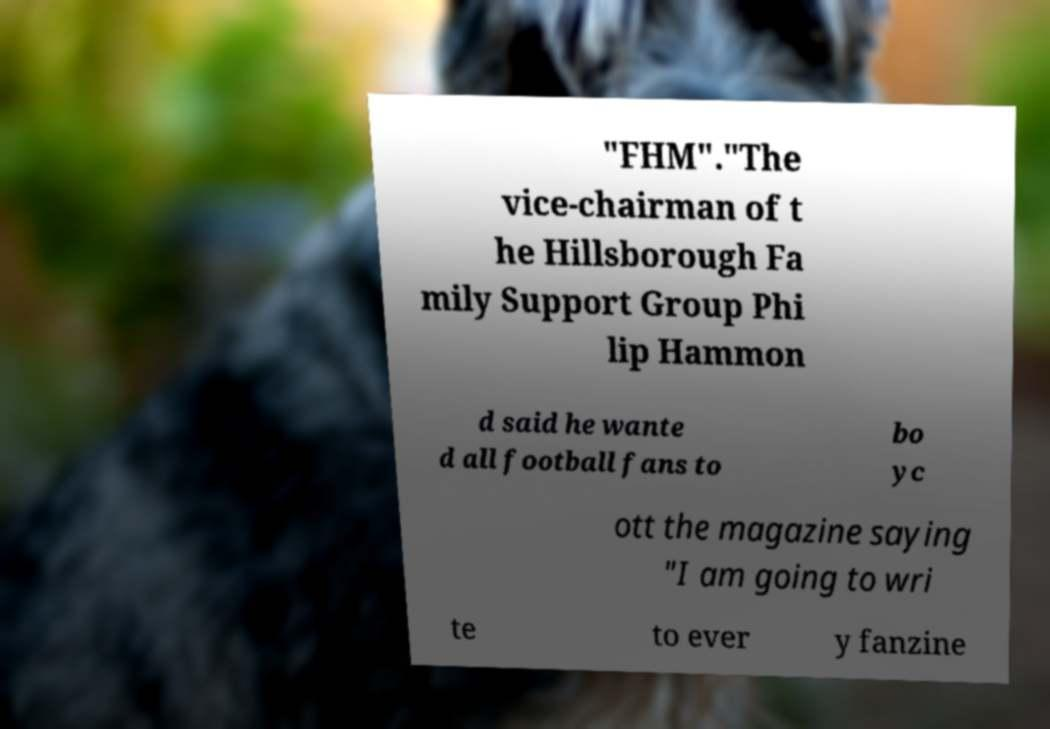I need the written content from this picture converted into text. Can you do that? "FHM"."The vice-chairman of t he Hillsborough Fa mily Support Group Phi lip Hammon d said he wante d all football fans to bo yc ott the magazine saying "I am going to wri te to ever y fanzine 